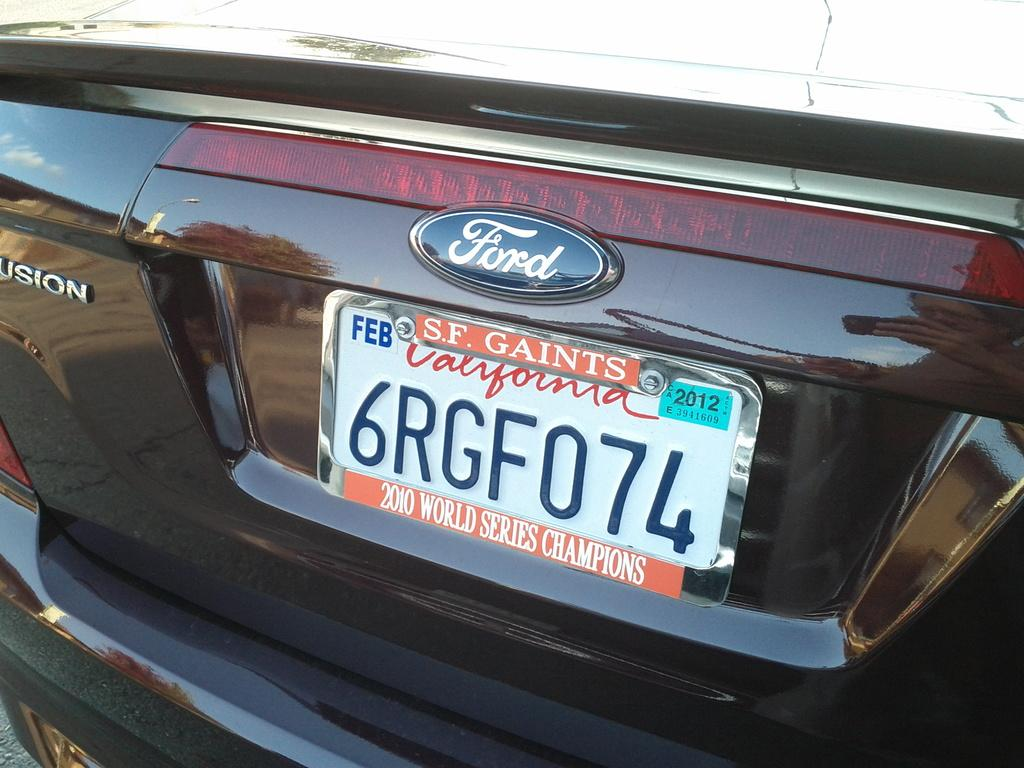<image>
Create a compact narrative representing the image presented. A Ford car has a California license plate with an SF Giants frame 